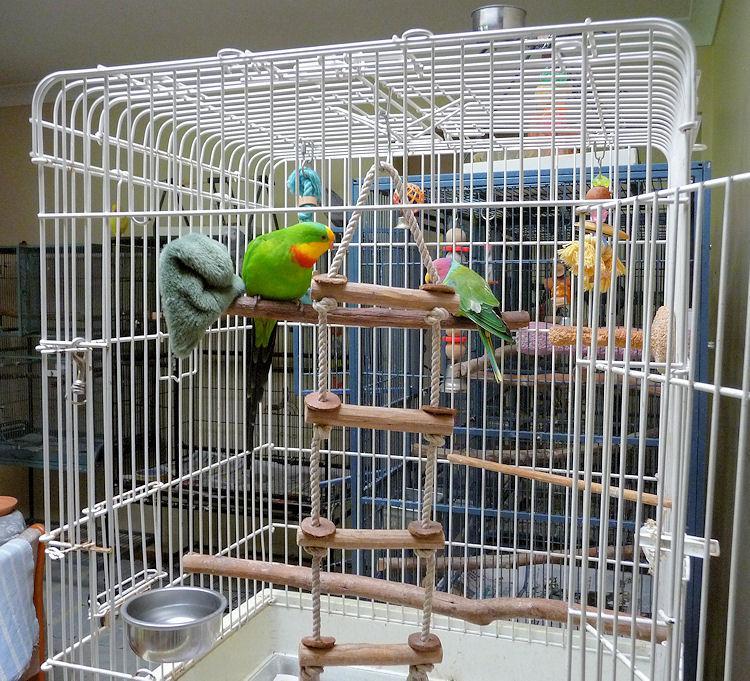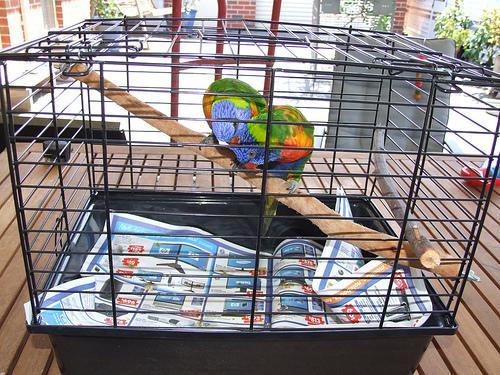The first image is the image on the left, the second image is the image on the right. Evaluate the accuracy of this statement regarding the images: "All of the birds have blue heads and orange/yellow bellies.". Is it true? Answer yes or no. No. 